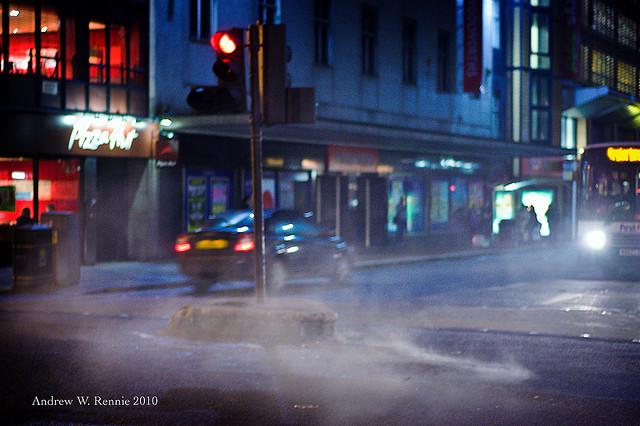What time of day is it?
Quick response, please. Night. Does the traffic light allow a car to move forward?
Answer briefly. No. What color is the light?
Answer briefly. Red. 